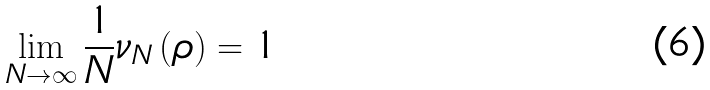<formula> <loc_0><loc_0><loc_500><loc_500>\lim _ { N \rightarrow \infty } \frac { 1 } { N } \nu _ { N } \left ( \rho \right ) = 1</formula> 